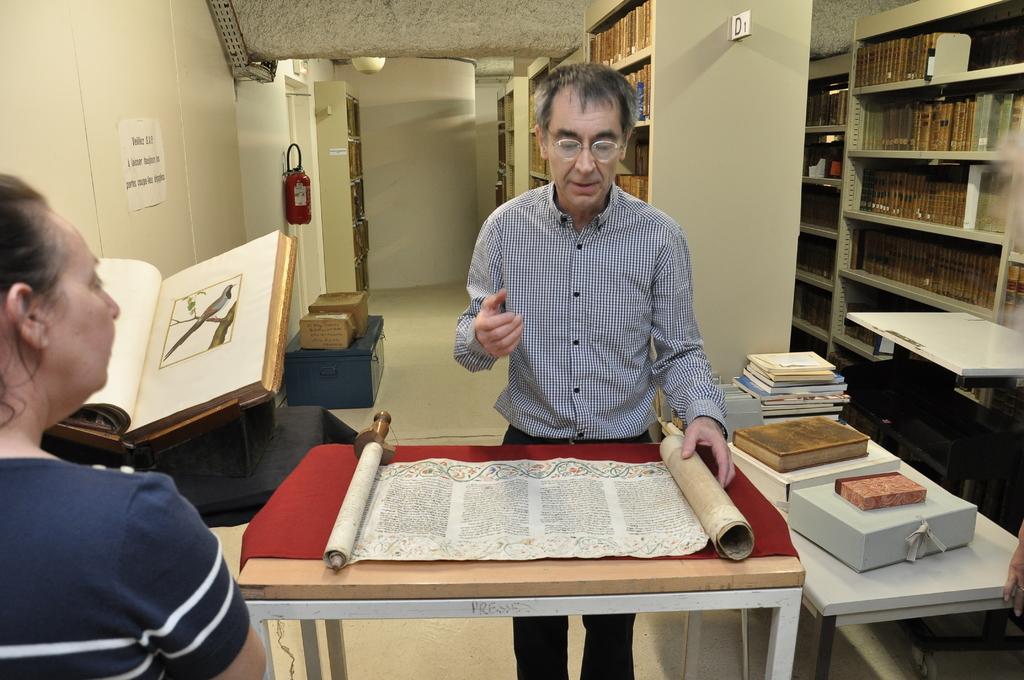Can you describe this image briefly? In this image I can see a man and a woman. Here on this table I can see a scroll and a book. In the background I can see number of books. 